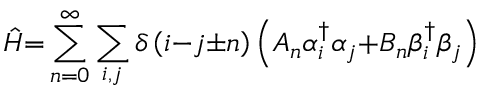Convert formula to latex. <formula><loc_0><loc_0><loc_500><loc_500>\hat { H } { = } \sum _ { n { = 0 } } ^ { \infty } { \sum _ { i , j } { \delta \left ( i { - } j { \pm } n \right ) \left ( A _ { n } { \alpha } _ { i } ^ { \dagger } { \alpha } _ { j } { + } B _ { n } { \beta } _ { i } ^ { \dagger } { \beta } _ { j } \right ) } }</formula> 